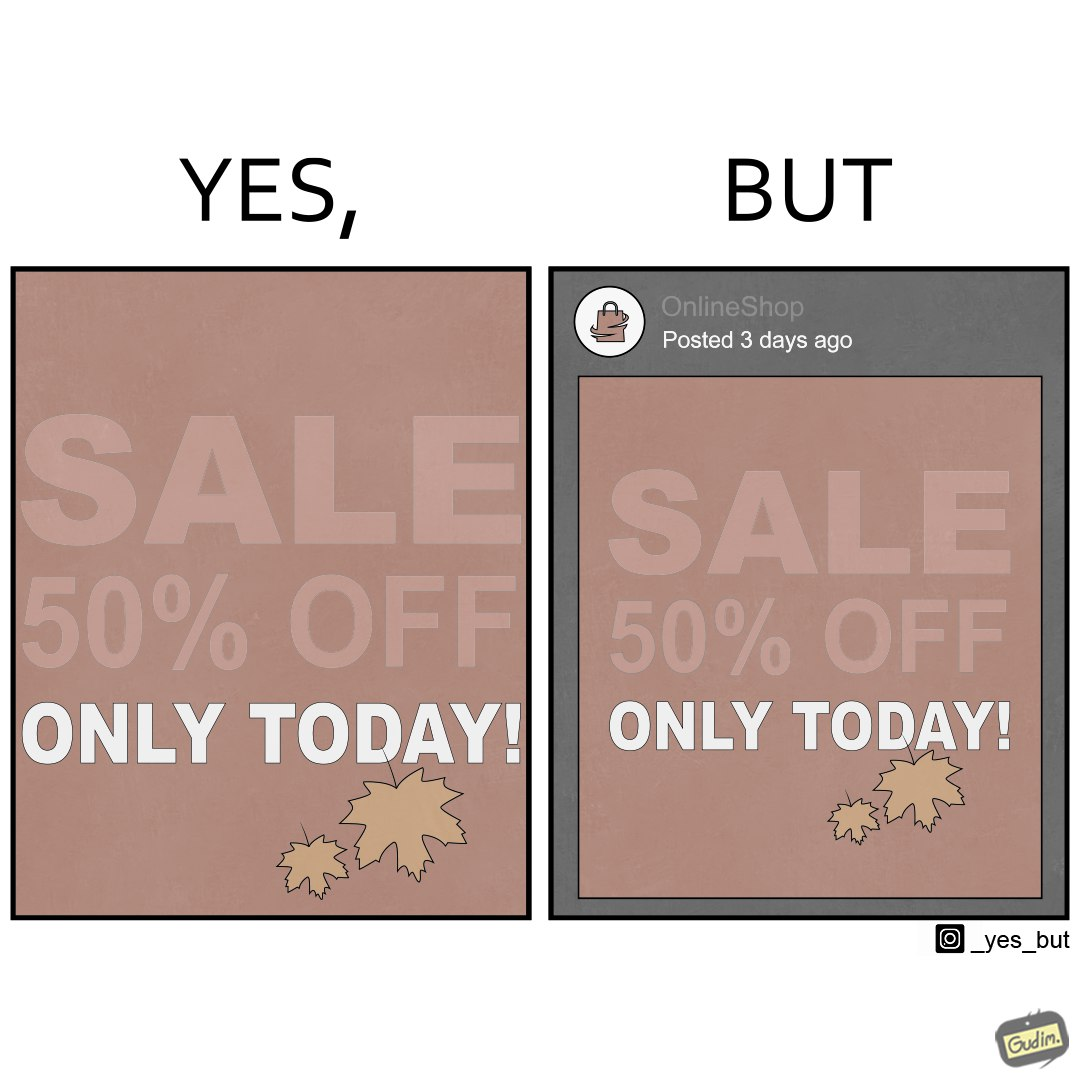What is shown in the left half versus the right half of this image? In the left part of the image: a poster suggesting a sale of 50% off on a particular day In the right part of the image: a post posted by a social media account, named as OnlineShop, 3 days ago showing an image of a poster suggesting a sale of 50% off on a particular day 